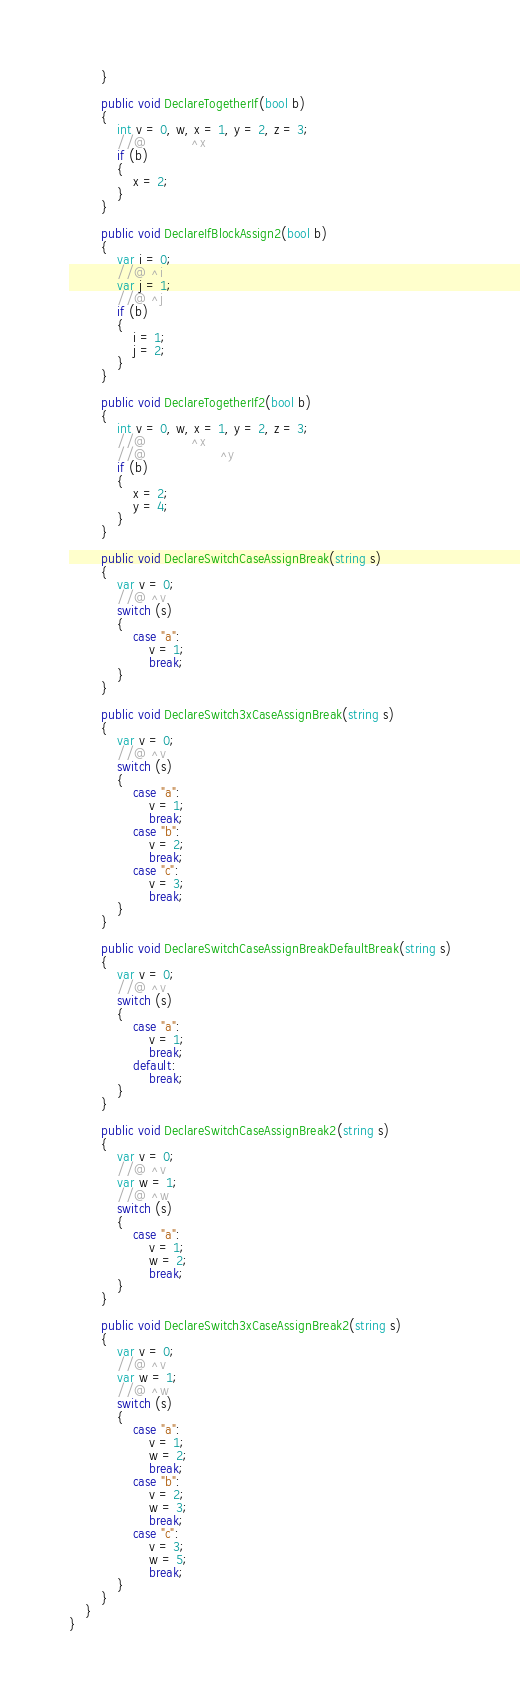<code> <loc_0><loc_0><loc_500><loc_500><_C#_>        }

        public void DeclareTogetherIf(bool b)
        {
            int v = 0, w, x = 1, y = 2, z = 3;
            //@           ^x
            if (b)
            {
                x = 2;
            }
        }

        public void DeclareIfBlockAssign2(bool b)
        {
            var i = 0;
            //@ ^i
            var j = 1;
            //@ ^j
            if (b)
            {
                i = 1;
                j = 2;
            }
        }

        public void DeclareTogetherIf2(bool b)
        {
            int v = 0, w, x = 1, y = 2, z = 3;
            //@           ^x
            //@                  ^y
            if (b)
            {
                x = 2;
                y = 4;
            }
        }

        public void DeclareSwitchCaseAssignBreak(string s)
        {
            var v = 0;
            //@ ^v
            switch (s)
            {
                case "a":
                    v = 1;
                    break;
            }
        }

        public void DeclareSwitch3xCaseAssignBreak(string s)
        {
            var v = 0;
            //@ ^v
            switch (s)
            {
                case "a":
                    v = 1;
                    break;
                case "b":
                    v = 2;
                    break;
                case "c":
                    v = 3;
                    break;
            }
        }

        public void DeclareSwitchCaseAssignBreakDefaultBreak(string s)
        {
            var v = 0;
            //@ ^v
            switch (s)
            {
                case "a":
                    v = 1;
                    break;
                default:
                    break;
            }
        }

        public void DeclareSwitchCaseAssignBreak2(string s)
        {
            var v = 0;
            //@ ^v
            var w = 1;
            //@ ^w
            switch (s)
            {
                case "a":
                    v = 1;
                    w = 2;
                    break;
            }
        }

        public void DeclareSwitch3xCaseAssignBreak2(string s)
        {
            var v = 0;
            //@ ^v
            var w = 1;
            //@ ^w
            switch (s)
            {
                case "a":
                    v = 1;
                    w = 2;
                    break;
                case "b":
                    v = 2;
                    w = 3;
                    break;
                case "c":
                    v = 3;
                    w = 5;
                    break;
            }
        }
    }
}
</code> 